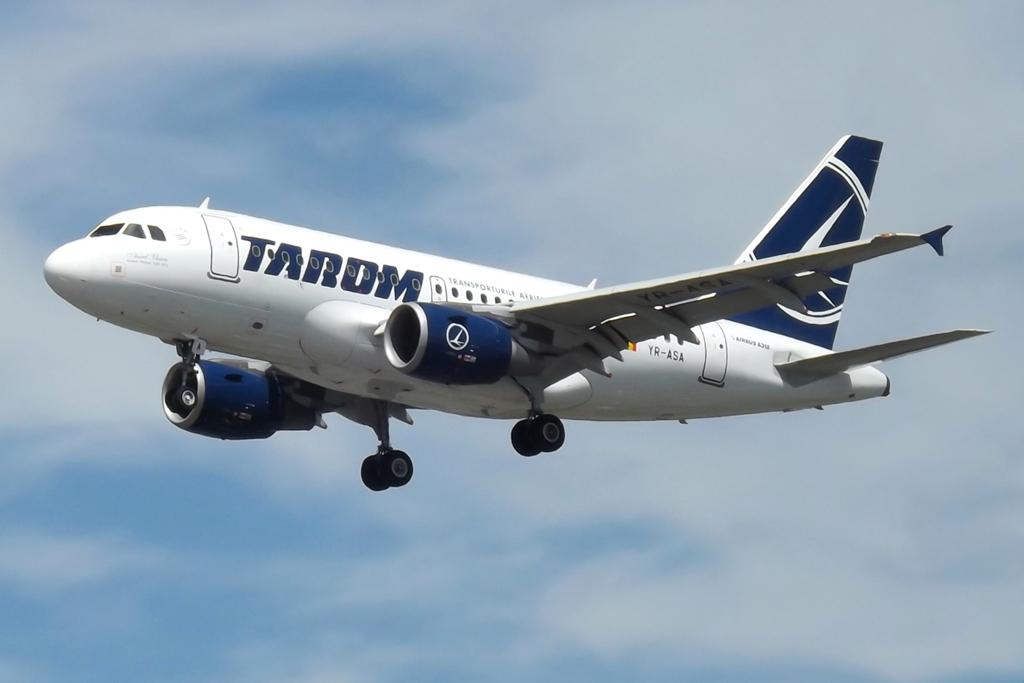Which airline does this plane belong too?
Your response must be concise. Tarom. 